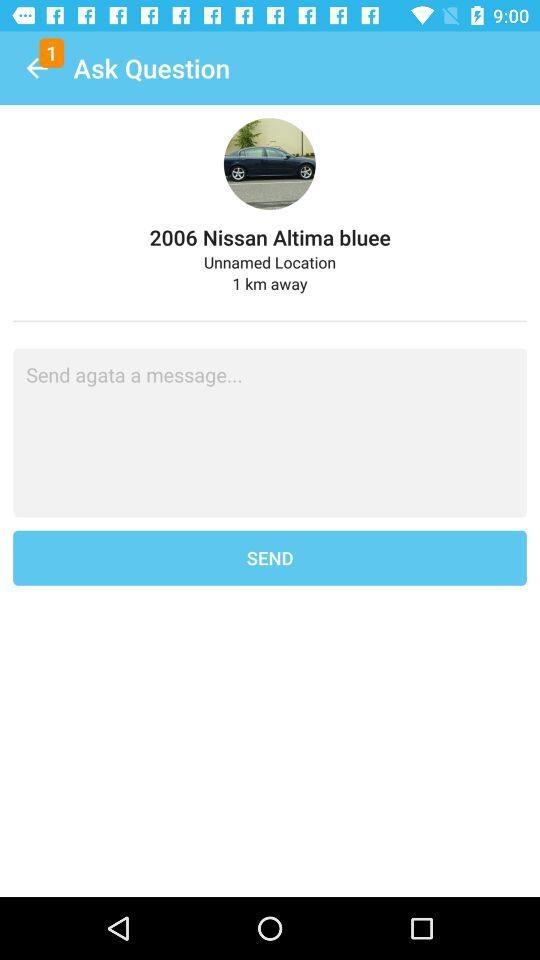How many kilometres away is the location? The location is 1 km away. 